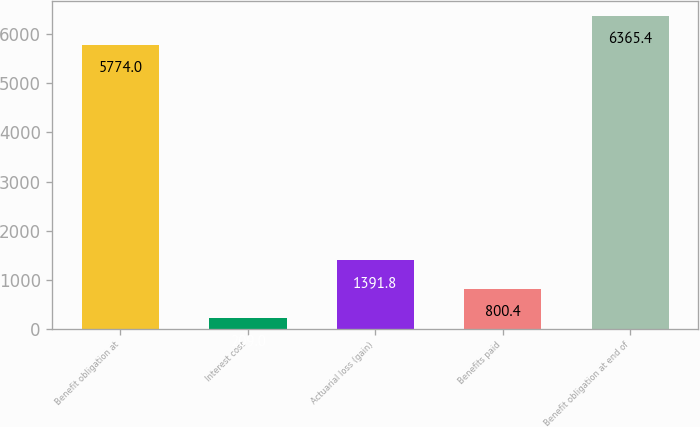Convert chart. <chart><loc_0><loc_0><loc_500><loc_500><bar_chart><fcel>Benefit obligation at<fcel>Interest cost<fcel>Actuarial loss (gain)<fcel>Benefits paid<fcel>Benefit obligation at end of<nl><fcel>5774<fcel>209<fcel>1391.8<fcel>800.4<fcel>6365.4<nl></chart> 